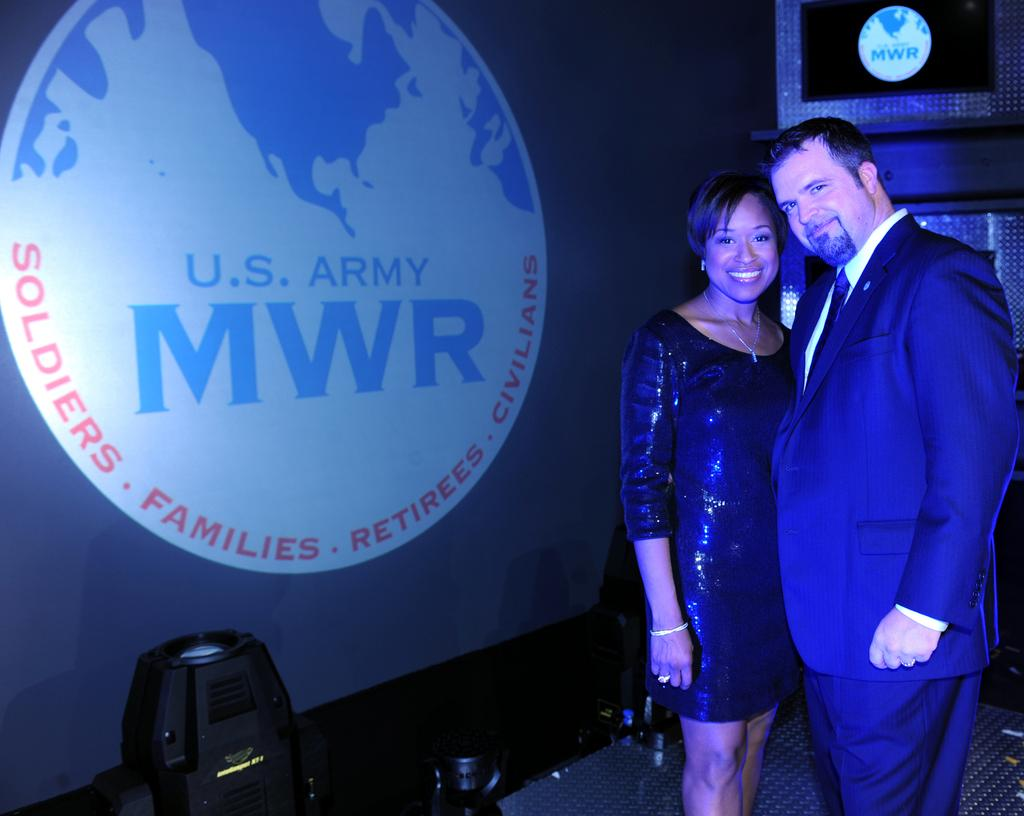How many people are in the image? There are two people in the image, a man and a woman. What are the man and woman doing in the image? The man and woman are posing for a camera and smiling. What type of surface is visible in the image? There is a floor in the image. What can be seen in the background of the image? There is a banner in the background of the image. How many balloons are being held by the rabbits in the image? There are no rabbits or balloons present in the image. What type of swing is the man using in the image? There is no swing present in the image; the man and woman are posing for a camera while standing on a floor. 